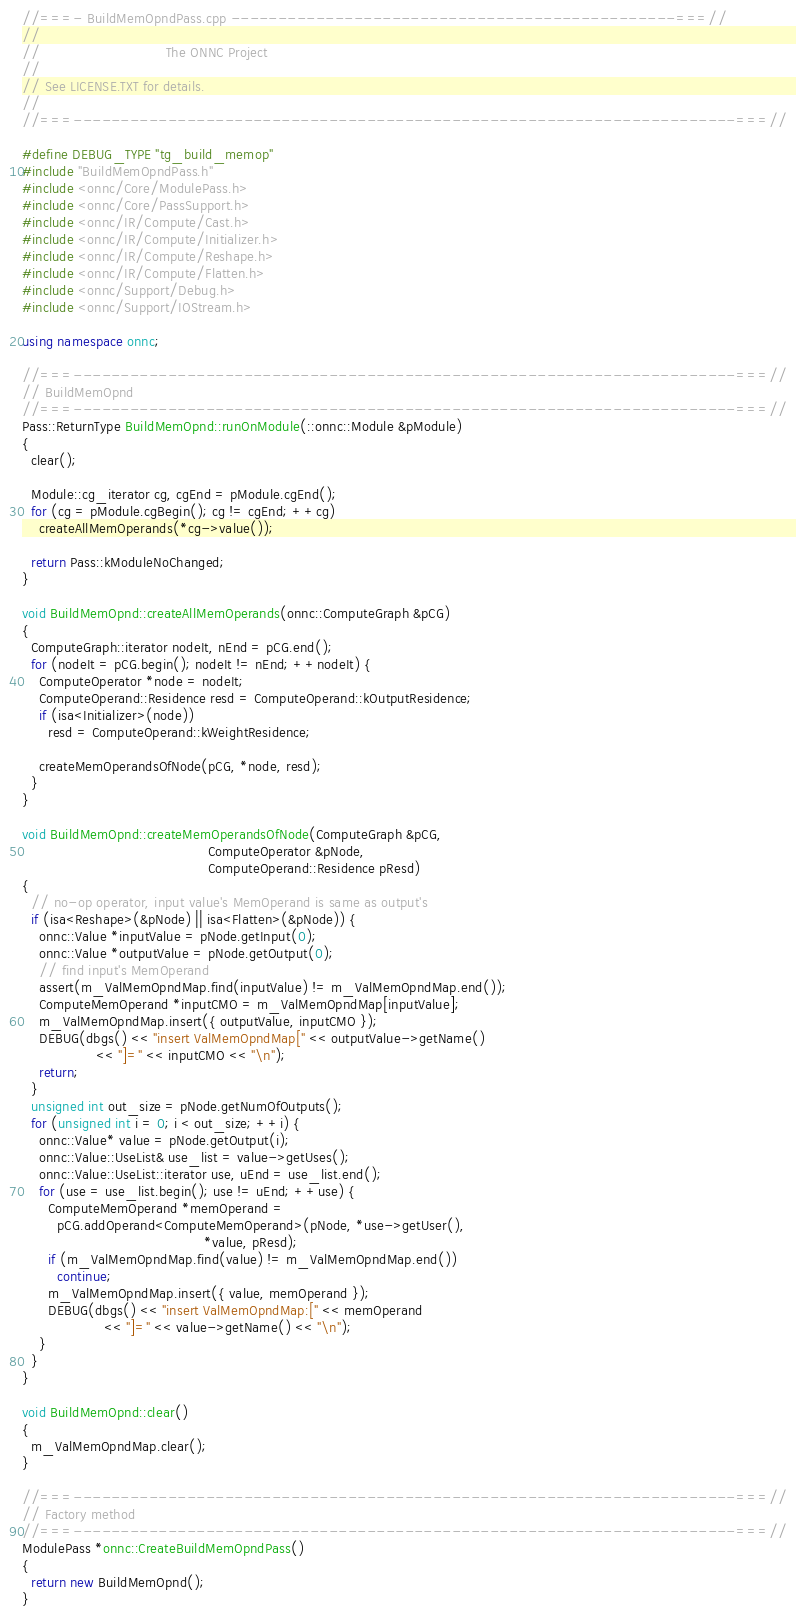Convert code to text. <code><loc_0><loc_0><loc_500><loc_500><_C++_>//===- BuildMemOpndPass.cpp -----------------------------------------------===//
//
//                             The ONNC Project
//
// See LICENSE.TXT for details.
//
//===----------------------------------------------------------------------===//

#define DEBUG_TYPE "tg_build_memop"
#include "BuildMemOpndPass.h"
#include <onnc/Core/ModulePass.h>
#include <onnc/Core/PassSupport.h>
#include <onnc/IR/Compute/Cast.h>
#include <onnc/IR/Compute/Initializer.h>
#include <onnc/IR/Compute/Reshape.h>
#include <onnc/IR/Compute/Flatten.h>
#include <onnc/Support/Debug.h>
#include <onnc/Support/IOStream.h>

using namespace onnc;

//===----------------------------------------------------------------------===//
// BuildMemOpnd
//===----------------------------------------------------------------------===//
Pass::ReturnType BuildMemOpnd::runOnModule(::onnc::Module &pModule)
{
  clear();

  Module::cg_iterator cg, cgEnd = pModule.cgEnd();
  for (cg = pModule.cgBegin(); cg != cgEnd; ++cg)
    createAllMemOperands(*cg->value());

  return Pass::kModuleNoChanged;
}

void BuildMemOpnd::createAllMemOperands(onnc::ComputeGraph &pCG)
{
  ComputeGraph::iterator nodeIt, nEnd = pCG.end();
  for (nodeIt = pCG.begin(); nodeIt != nEnd; ++nodeIt) {
    ComputeOperator *node = nodeIt;
    ComputeOperand::Residence resd = ComputeOperand::kOutputResidence;
    if (isa<Initializer>(node))
      resd = ComputeOperand::kWeightResidence;

    createMemOperandsOfNode(pCG, *node, resd);
  }
}

void BuildMemOpnd::createMemOperandsOfNode(ComputeGraph &pCG,
                                           ComputeOperator &pNode,
                                           ComputeOperand::Residence pResd)
{
  // no-op operator, input value's MemOperand is same as output's
  if (isa<Reshape>(&pNode) || isa<Flatten>(&pNode)) {
    onnc::Value *inputValue = pNode.getInput(0);
    onnc::Value *outputValue = pNode.getOutput(0);
    // find input's MemOperand
    assert(m_ValMemOpndMap.find(inputValue) != m_ValMemOpndMap.end());
    ComputeMemOperand *inputCMO = m_ValMemOpndMap[inputValue];
    m_ValMemOpndMap.insert({ outputValue, inputCMO });
    DEBUG(dbgs() << "insert ValMemOpndMap[" << outputValue->getName()
                 << "]=" << inputCMO << "\n");
    return;
  }
  unsigned int out_size = pNode.getNumOfOutputs();
  for (unsigned int i = 0; i < out_size; ++i) {
    onnc::Value* value = pNode.getOutput(i);
    onnc::Value::UseList& use_list = value->getUses();
    onnc::Value::UseList::iterator use, uEnd = use_list.end();
    for (use = use_list.begin(); use != uEnd; ++use) {
      ComputeMemOperand *memOperand =
        pCG.addOperand<ComputeMemOperand>(pNode, *use->getUser(),
                                          *value, pResd);
      if (m_ValMemOpndMap.find(value) != m_ValMemOpndMap.end())
        continue;
      m_ValMemOpndMap.insert({ value, memOperand });
      DEBUG(dbgs() << "insert ValMemOpndMap:[" << memOperand
                   << "]=" << value->getName() << "\n");
    }
  }
}

void BuildMemOpnd::clear()
{
  m_ValMemOpndMap.clear();
}

//===----------------------------------------------------------------------===//
// Factory method
//===----------------------------------------------------------------------===//
ModulePass *onnc::CreateBuildMemOpndPass()
{
  return new BuildMemOpnd();
}
</code> 